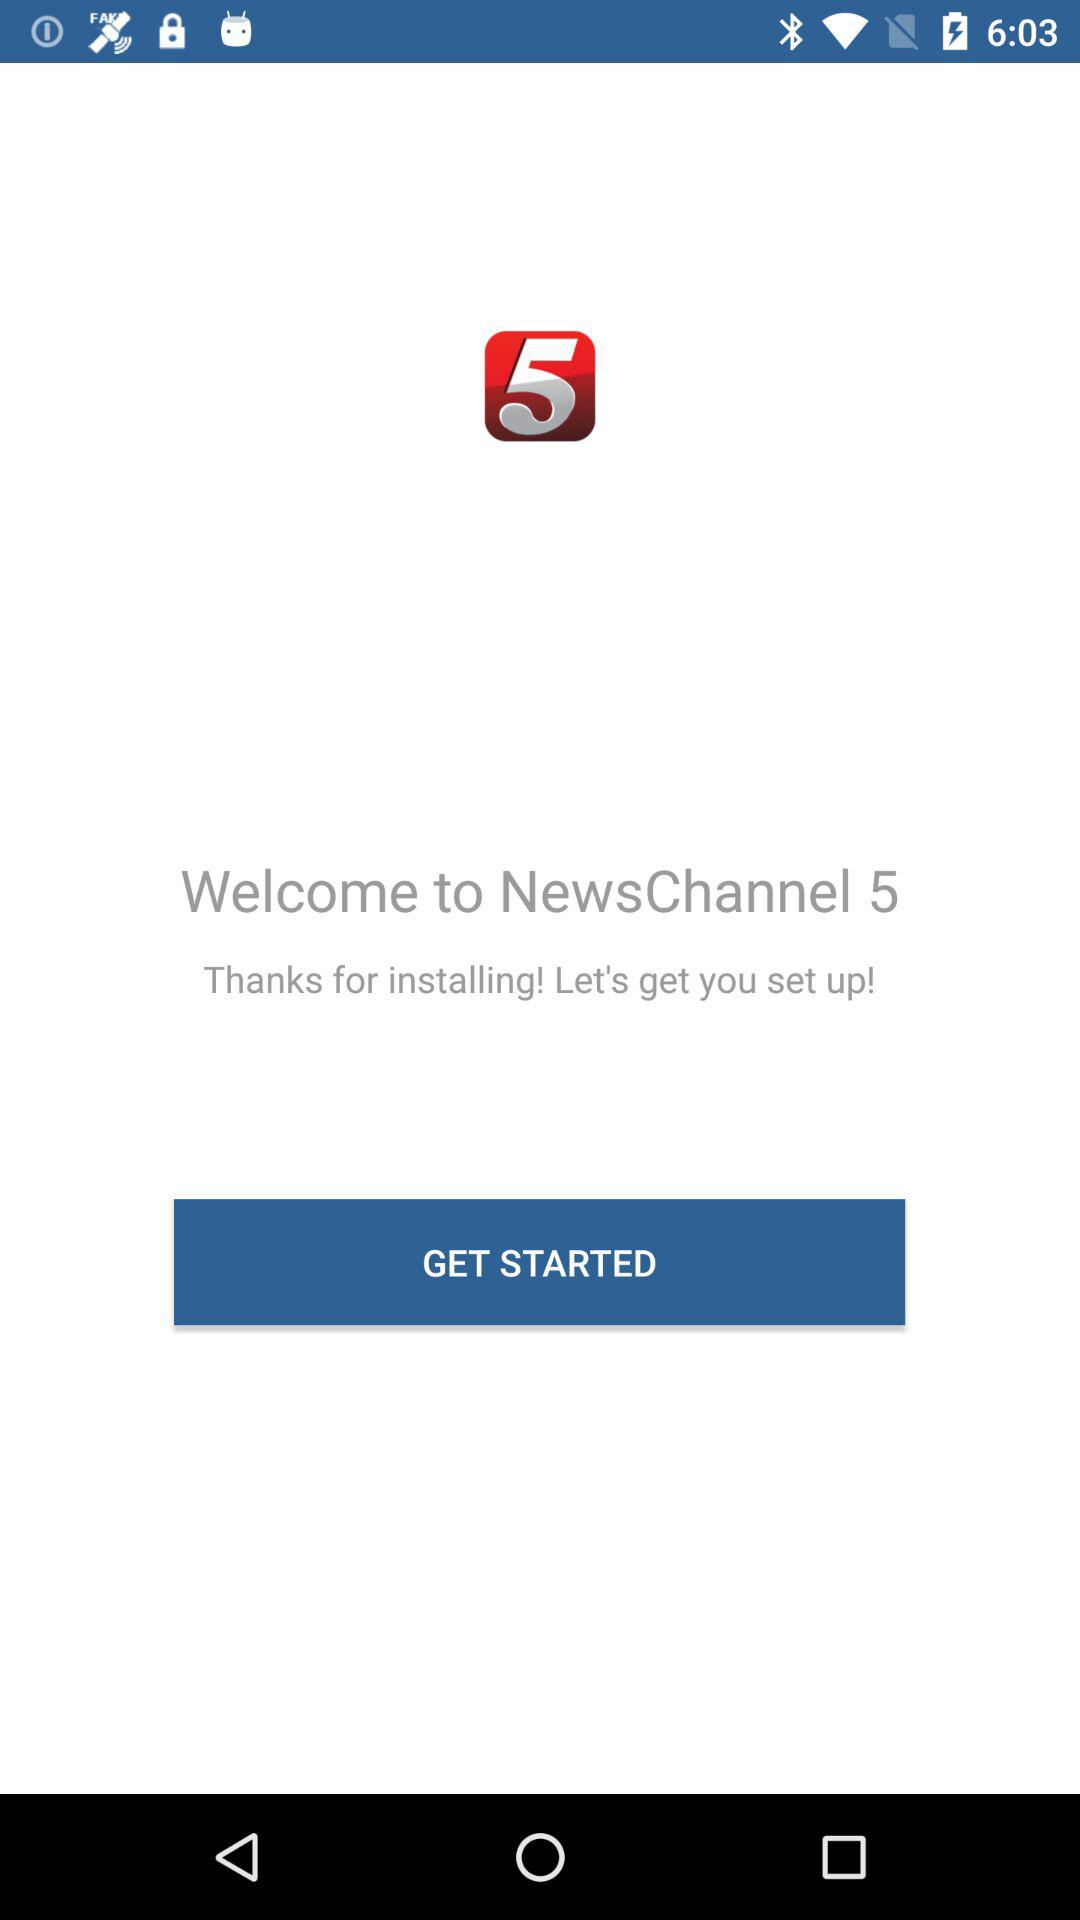What is the name of the application? The name of the application is "NewsChannel 5". 